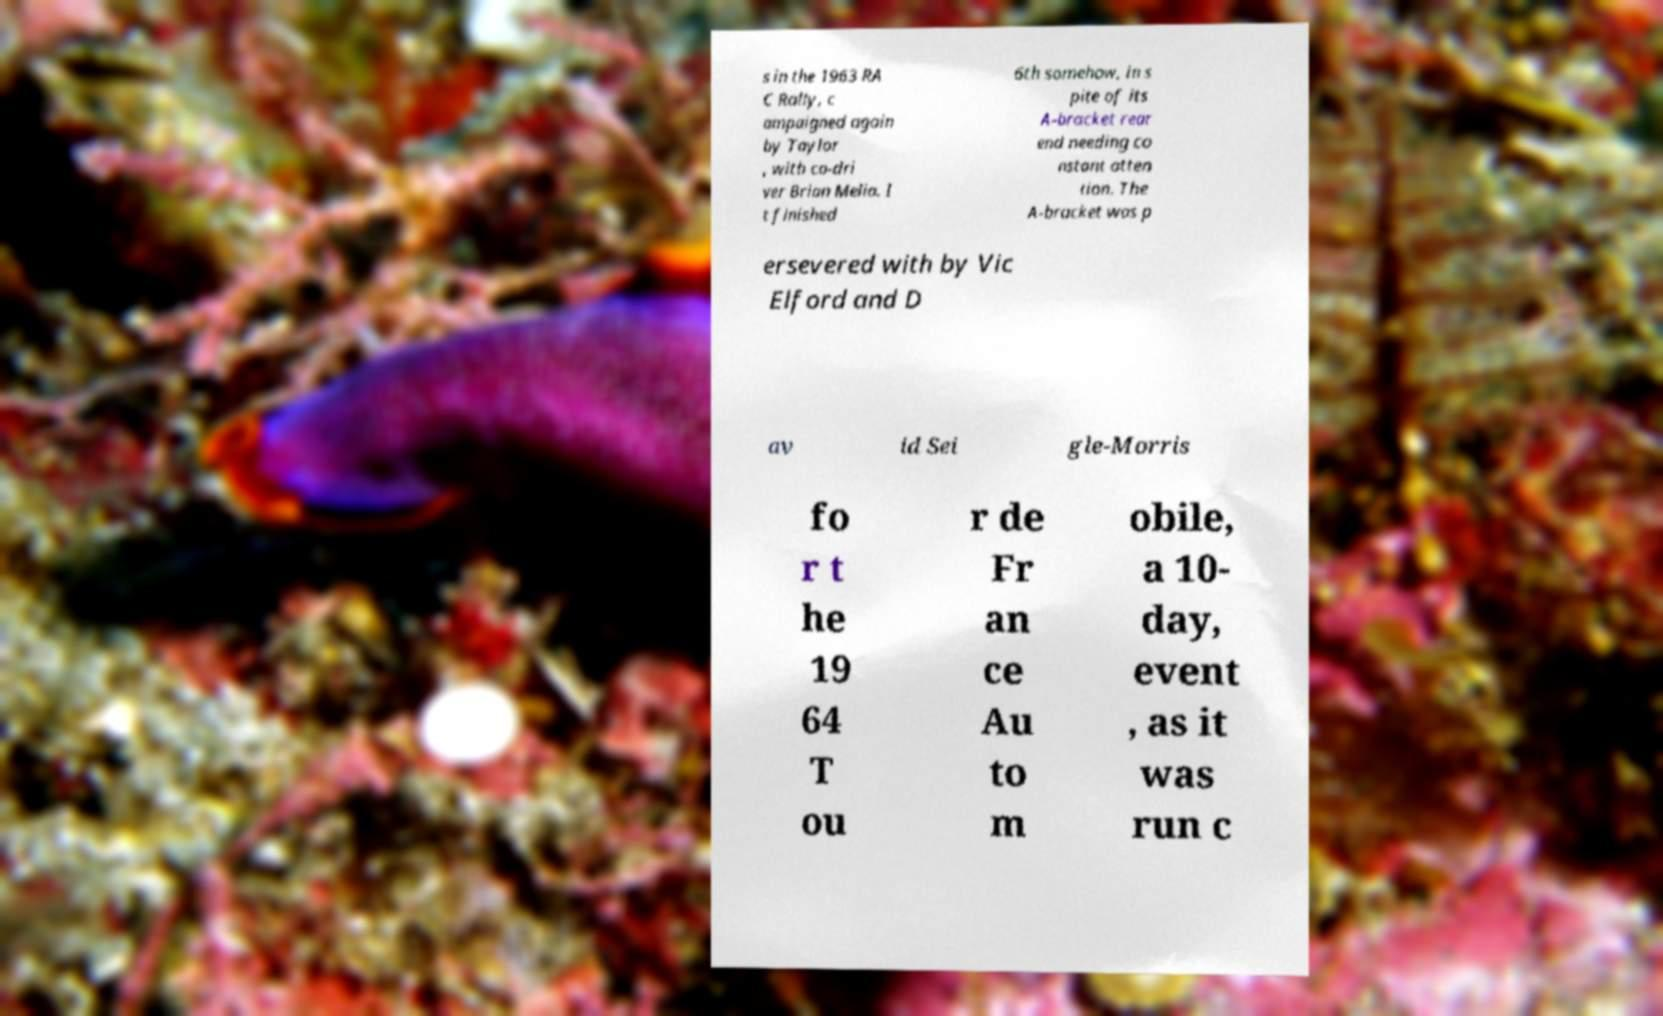Could you assist in decoding the text presented in this image and type it out clearly? s in the 1963 RA C Rally, c ampaigned again by Taylor , with co-dri ver Brian Melia. I t finished 6th somehow, in s pite of its A-bracket rear end needing co nstant atten tion. The A-bracket was p ersevered with by Vic Elford and D av id Sei gle-Morris fo r t he 19 64 T ou r de Fr an ce Au to m obile, a 10- day, event , as it was run c 